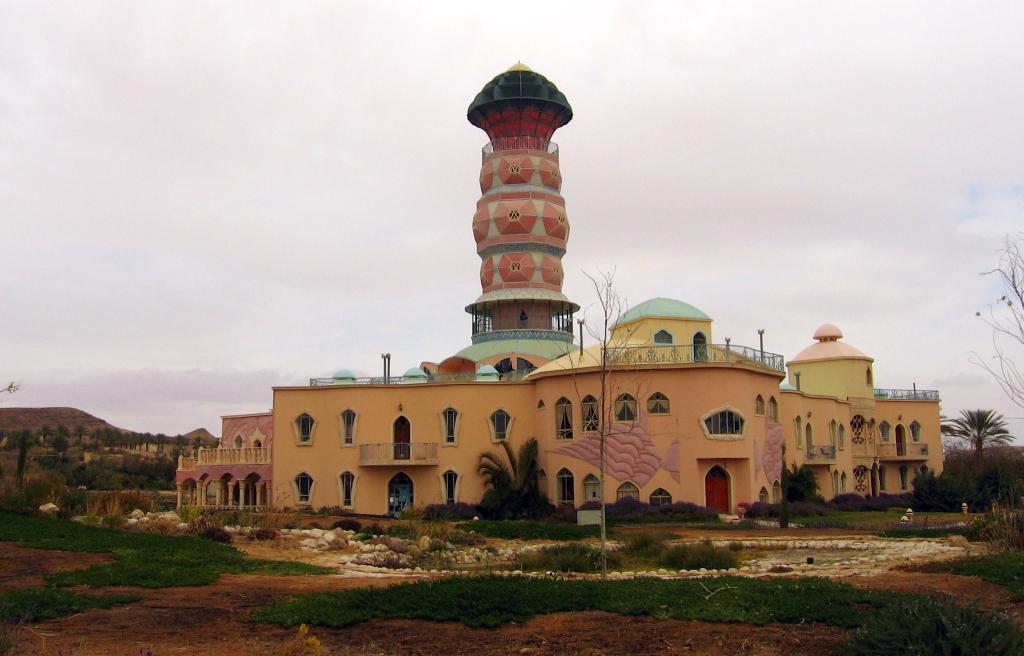Can you describe this image briefly? In the center of the image we can see tower, buildings and trees. At the bottom of the image we can see stones, trees and grass. In the background we can see hill, trees, sky and clouds. 